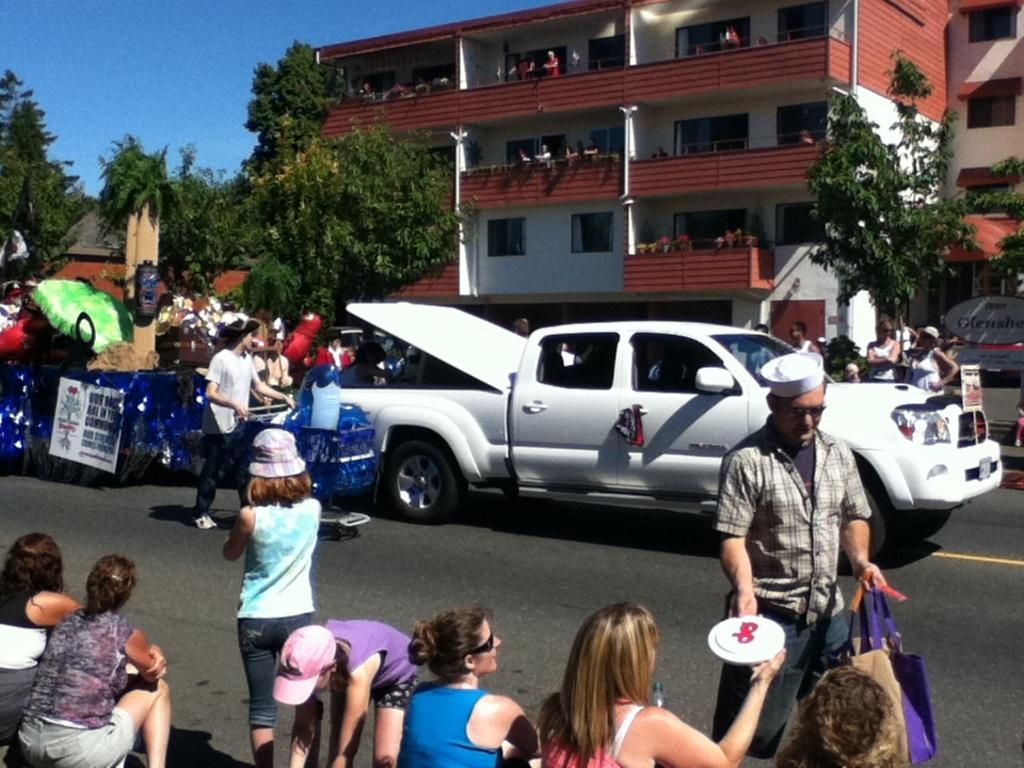Can you describe this image briefly? This picture is taken on the wide road. In this image, in the middle and in the left corner, we can see a group of people sitting. On the right side, we can see a person standing and holding a cover on one hand and plate on other hand. On the left side, we can also see a woman standing on the road. In the background, we can see a vehicle which is moving on the road, a group of people, posters, trees, buildings, in the building, we can also see a group of people, glass window. At the top, we can see a sky, at the bottom, we can see a road. 